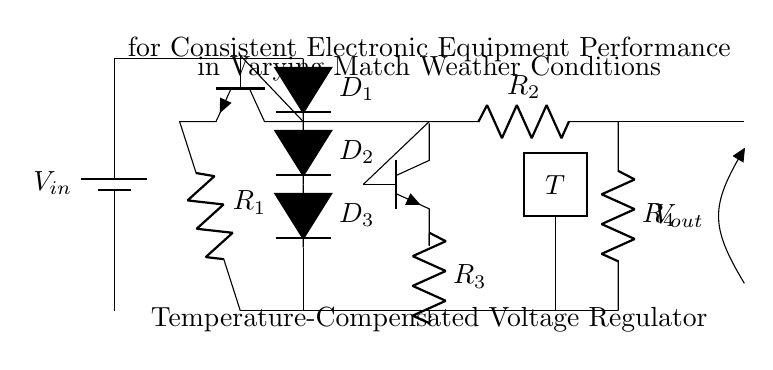What is the input voltage of the circuit? The input voltage, denoted as \( V_{in} \), is indicated next to the battery symbol. It represents the voltage supplied to the circuit.
Answer: \( V_{in} \) What is the function of the temperature sensor in this circuit? The temperature sensor, labeled \( T \), is used to detect temperature changes, which helps adjust the voltage output to maintain consistent performance under varying conditions.
Answer: Detect temperature How many resistors are present in the circuit? By counting the resistor symbols in the diagram, there are four resistors labeled \( R_1, R_2, R_3, \) and \( R_4 \).
Answer: Four Which components are used for voltage regulation? The transistors \( Q1 \) and \( Q2 \) work together to regulate the voltage, maintaining a consistent output regardless of input variations.
Answer: Transistors How are the diodes arranged in the circuit? The three diodes, \( D_1, D_2, \) and \( D_3 \), are arranged in a series configuration, as they are connected one after another in the diagram.
Answer: In series What is the purpose of using a temperature-compensated voltage regulator? The purpose is to ensure that the electronic equipment performs consistently despite temperature variations during matches, ultimately enhancing reliability and performance.
Answer: Maintain performance What is the output voltage labeled as in the circuit? The output voltage is labeled as \( V_{out} \), which indicates the voltage delivered to the electronic equipment following regulation.
Answer: \( V_{out} \) 